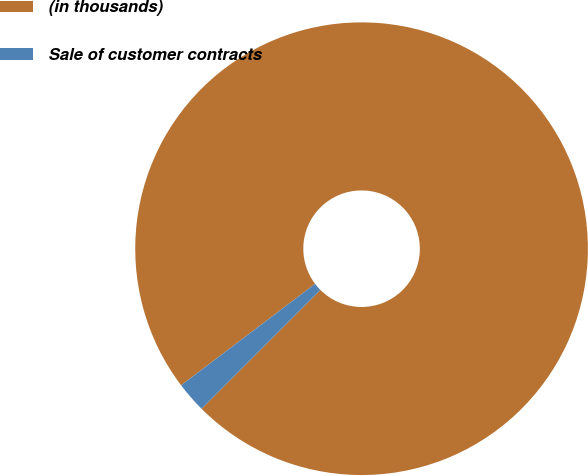Convert chart. <chart><loc_0><loc_0><loc_500><loc_500><pie_chart><fcel>(in thousands)<fcel>Sale of customer contracts<nl><fcel>97.81%<fcel>2.19%<nl></chart> 